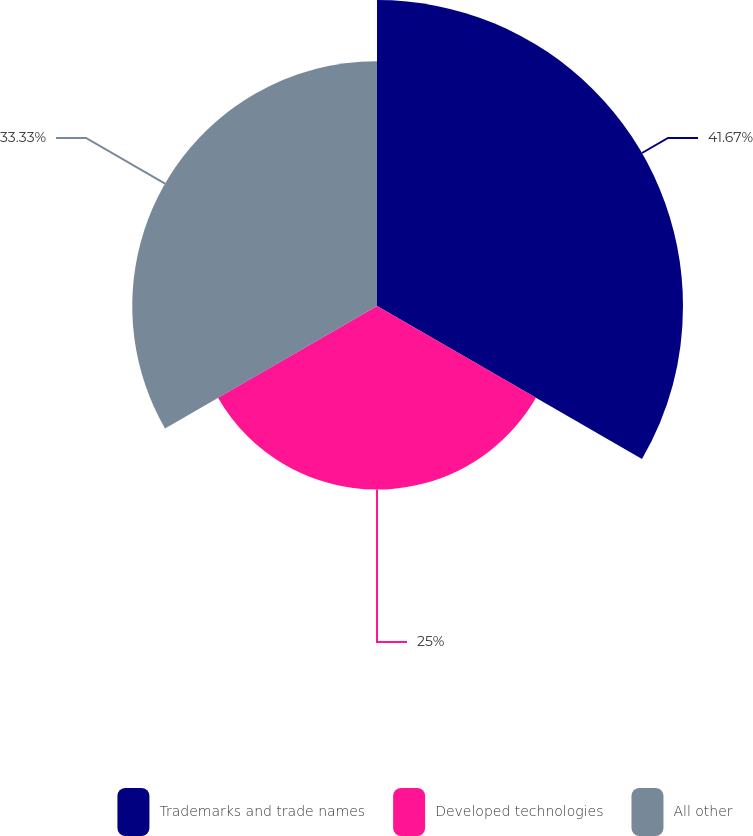Convert chart. <chart><loc_0><loc_0><loc_500><loc_500><pie_chart><fcel>Trademarks and trade names<fcel>Developed technologies<fcel>All other<nl><fcel>41.67%<fcel>25.0%<fcel>33.33%<nl></chart> 